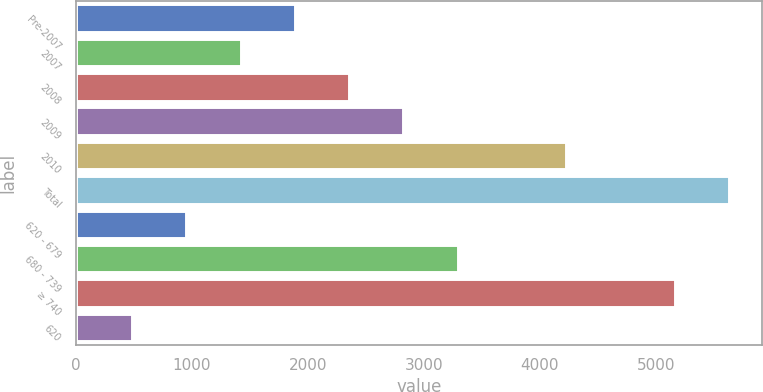Convert chart to OTSL. <chart><loc_0><loc_0><loc_500><loc_500><bar_chart><fcel>Pre-2007<fcel>2007<fcel>2008<fcel>2009<fcel>2010<fcel>Total<fcel>620 - 679<fcel>680 - 739<fcel>≥ 740<fcel>620<nl><fcel>1889.4<fcel>1421.8<fcel>2357<fcel>2824.6<fcel>4227.4<fcel>5630.2<fcel>954.2<fcel>3292.2<fcel>5162.6<fcel>486.6<nl></chart> 